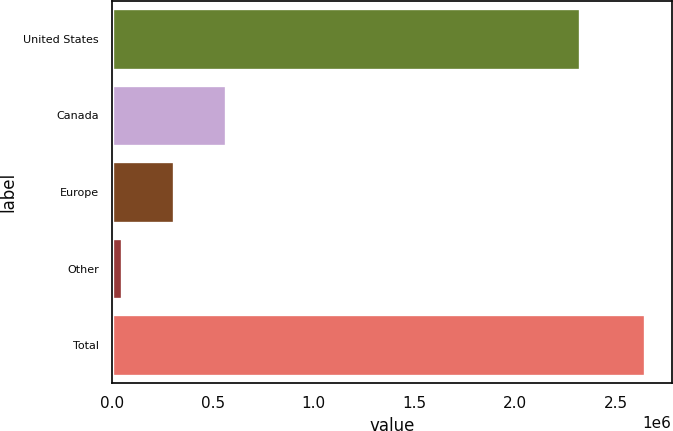<chart> <loc_0><loc_0><loc_500><loc_500><bar_chart><fcel>United States<fcel>Canada<fcel>Europe<fcel>Other<fcel>Total<nl><fcel>2.32252e+06<fcel>567680<fcel>307943<fcel>48206<fcel>2.64558e+06<nl></chart> 